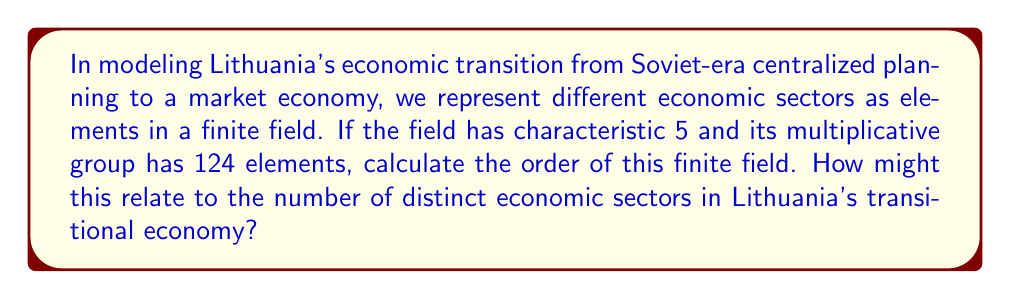Show me your answer to this math problem. Let's approach this step-by-step:

1) In a finite field $\mathbb{F}_q$, where $q$ is a prime power, the multiplicative group $\mathbb{F}_q^*$ has order $q-1$.

2) We're given that the multiplicative group has 124 elements, so:
   
   $q - 1 = 124$
   $q = 125$

3) We also know that the field has characteristic 5. This means $q$ must be a power of 5.

4) Indeed, $125 = 5^3$

5) Therefore, the order of the field is $5^3 = 125$.

6) In the context of Lithuania's economic transition, this could represent:
   - 5 main categories of economic sectors (represented by the characteristic)
   - 3 levels of development or privatization within each sector (represented by the exponent)
   - A total of 125 distinct economic sub-sectors or industries (represented by the field order)

This model could be used to analyze the complexity and diversity of Lithuania's evolving economy during its post-Soviet transformation.
Answer: $125$ 